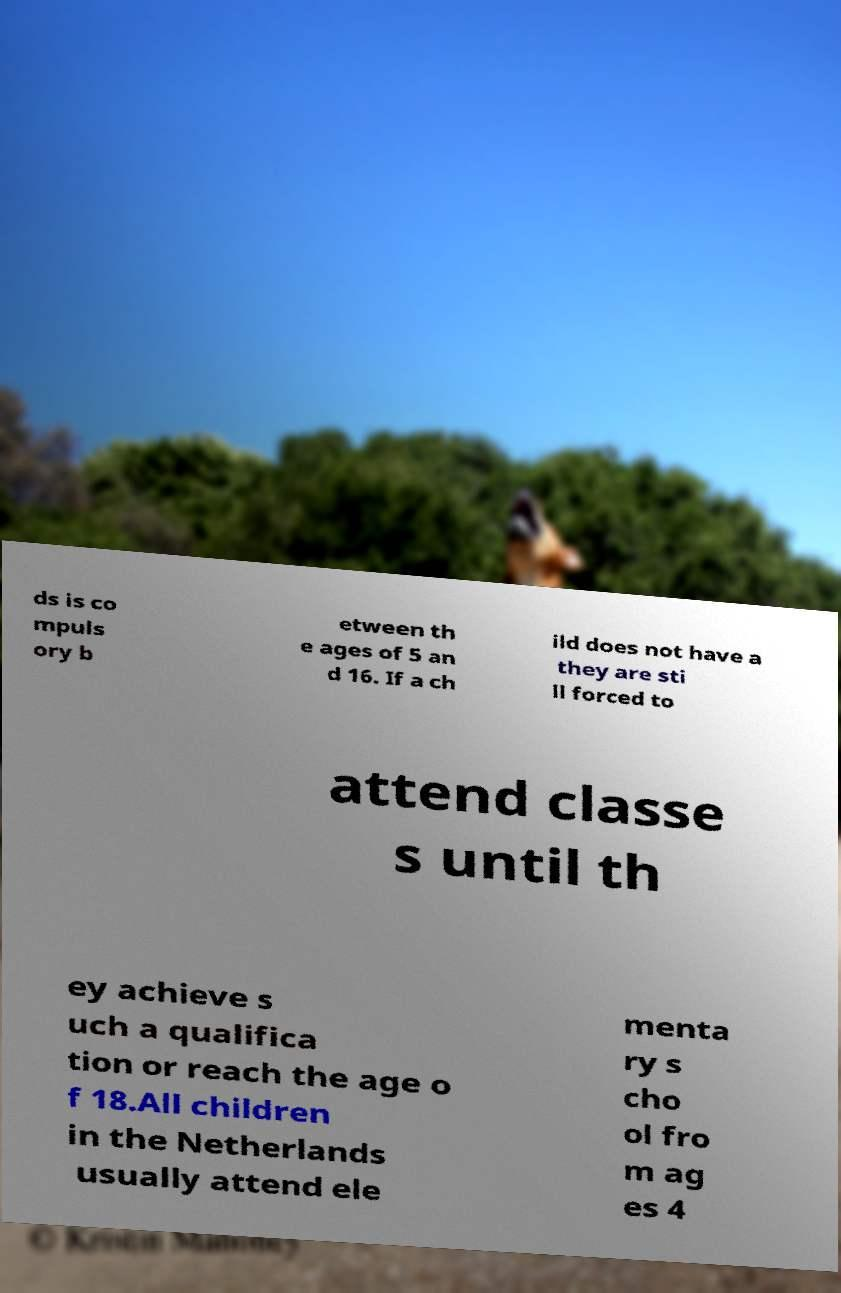What messages or text are displayed in this image? I need them in a readable, typed format. ds is co mpuls ory b etween th e ages of 5 an d 16. If a ch ild does not have a they are sti ll forced to attend classe s until th ey achieve s uch a qualifica tion or reach the age o f 18.All children in the Netherlands usually attend ele menta ry s cho ol fro m ag es 4 